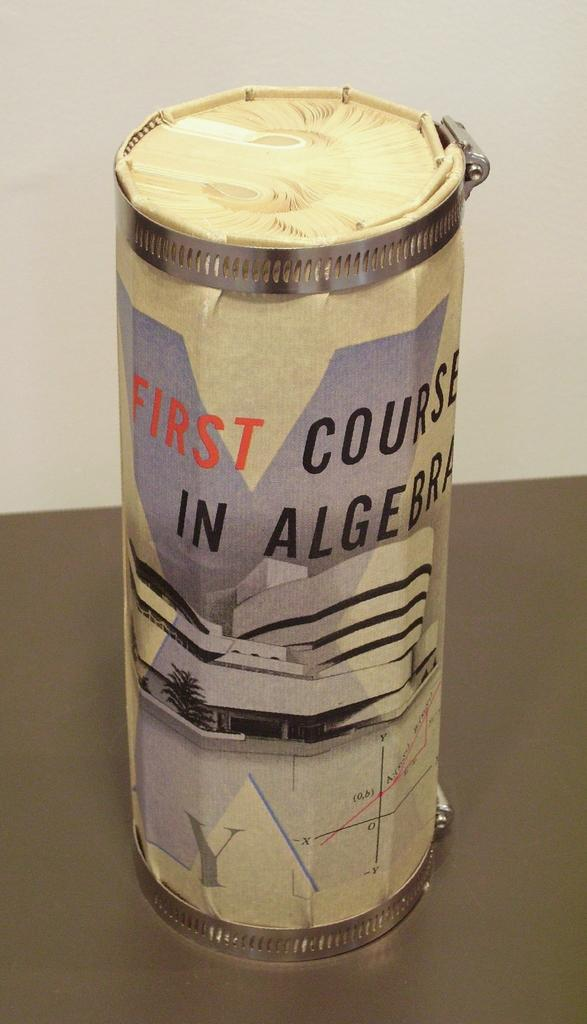<image>
Create a compact narrative representing the image presented. A paper tube is labeled "First Course in Algebra." 